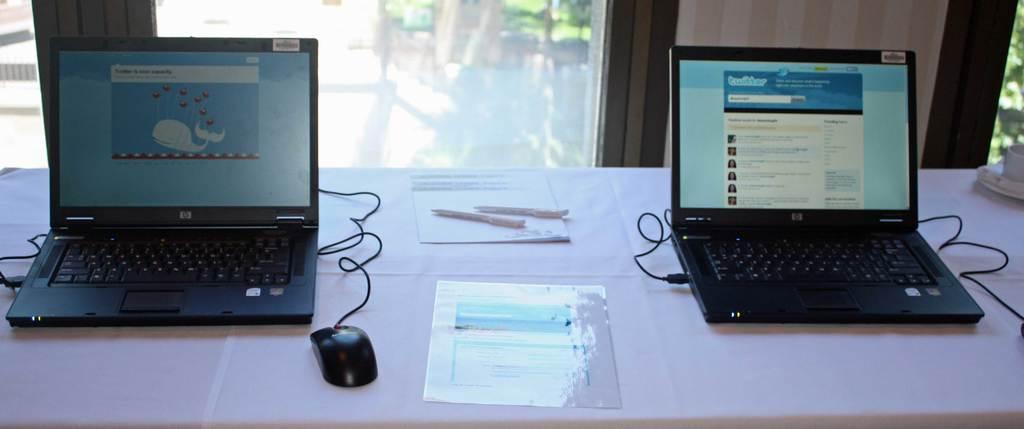How would you summarize this image in a sentence or two? There is a table and on the table there are two laptops and in between the laptops there are two papers and two pens, in front of the table there are windows and there is a wall in between the windows. 